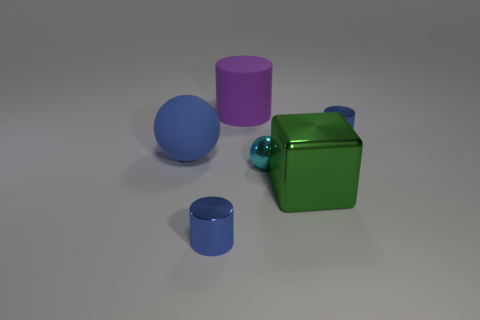Subtract all shiny cylinders. How many cylinders are left? 1 Add 3 green rubber spheres. How many objects exist? 9 Subtract all purple cylinders. How many cylinders are left? 2 Subtract all blocks. How many objects are left? 5 Add 1 green objects. How many green objects are left? 2 Add 4 tiny metal things. How many tiny metal things exist? 7 Subtract 0 yellow blocks. How many objects are left? 6 Subtract 2 balls. How many balls are left? 0 Subtract all green cylinders. Subtract all blue cubes. How many cylinders are left? 3 Subtract all blue spheres. How many blue cylinders are left? 2 